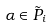<formula> <loc_0><loc_0><loc_500><loc_500>\alpha \in \tilde { P } _ { i }</formula> 